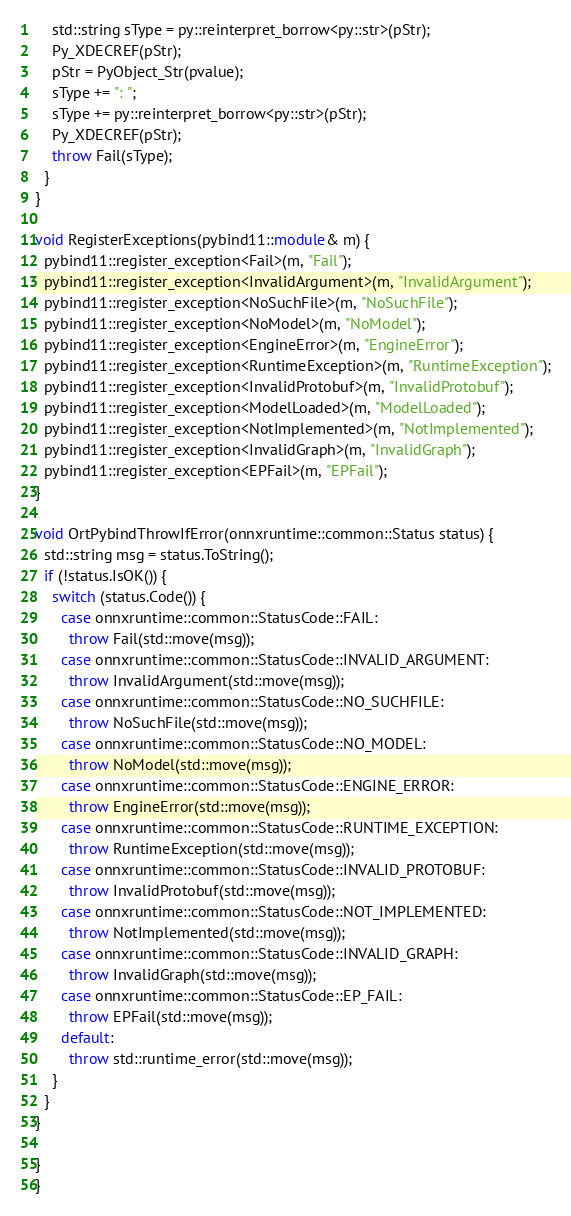<code> <loc_0><loc_0><loc_500><loc_500><_C++_>    std::string sType = py::reinterpret_borrow<py::str>(pStr);
    Py_XDECREF(pStr);
    pStr = PyObject_Str(pvalue);
    sType += ": ";
    sType += py::reinterpret_borrow<py::str>(pStr);
    Py_XDECREF(pStr);
    throw Fail(sType);
  }
}

void RegisterExceptions(pybind11::module& m) {
  pybind11::register_exception<Fail>(m, "Fail");
  pybind11::register_exception<InvalidArgument>(m, "InvalidArgument");
  pybind11::register_exception<NoSuchFile>(m, "NoSuchFile");
  pybind11::register_exception<NoModel>(m, "NoModel");
  pybind11::register_exception<EngineError>(m, "EngineError");
  pybind11::register_exception<RuntimeException>(m, "RuntimeException");
  pybind11::register_exception<InvalidProtobuf>(m, "InvalidProtobuf");
  pybind11::register_exception<ModelLoaded>(m, "ModelLoaded");
  pybind11::register_exception<NotImplemented>(m, "NotImplemented");
  pybind11::register_exception<InvalidGraph>(m, "InvalidGraph");
  pybind11::register_exception<EPFail>(m, "EPFail");
}

void OrtPybindThrowIfError(onnxruntime::common::Status status) {
  std::string msg = status.ToString();
  if (!status.IsOK()) {
    switch (status.Code()) {
      case onnxruntime::common::StatusCode::FAIL:
        throw Fail(std::move(msg));
      case onnxruntime::common::StatusCode::INVALID_ARGUMENT:
        throw InvalidArgument(std::move(msg));
      case onnxruntime::common::StatusCode::NO_SUCHFILE:
        throw NoSuchFile(std::move(msg));
      case onnxruntime::common::StatusCode::NO_MODEL:
        throw NoModel(std::move(msg));
      case onnxruntime::common::StatusCode::ENGINE_ERROR:
        throw EngineError(std::move(msg));
      case onnxruntime::common::StatusCode::RUNTIME_EXCEPTION:
        throw RuntimeException(std::move(msg));
      case onnxruntime::common::StatusCode::INVALID_PROTOBUF:
        throw InvalidProtobuf(std::move(msg));
      case onnxruntime::common::StatusCode::NOT_IMPLEMENTED:
        throw NotImplemented(std::move(msg));
      case onnxruntime::common::StatusCode::INVALID_GRAPH:
        throw InvalidGraph(std::move(msg));
      case onnxruntime::common::StatusCode::EP_FAIL:
        throw EPFail(std::move(msg));
      default:
        throw std::runtime_error(std::move(msg));
    }
  }
}

}
}</code> 